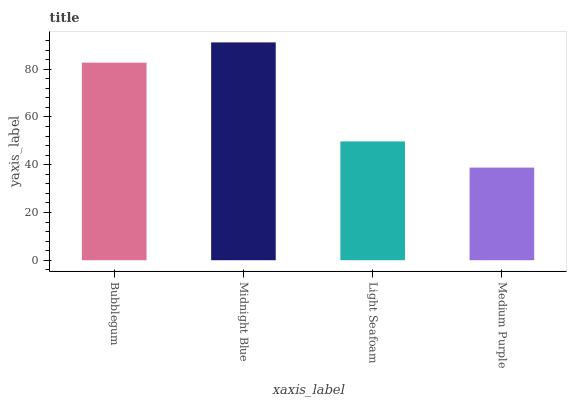Is Medium Purple the minimum?
Answer yes or no. Yes. Is Midnight Blue the maximum?
Answer yes or no. Yes. Is Light Seafoam the minimum?
Answer yes or no. No. Is Light Seafoam the maximum?
Answer yes or no. No. Is Midnight Blue greater than Light Seafoam?
Answer yes or no. Yes. Is Light Seafoam less than Midnight Blue?
Answer yes or no. Yes. Is Light Seafoam greater than Midnight Blue?
Answer yes or no. No. Is Midnight Blue less than Light Seafoam?
Answer yes or no. No. Is Bubblegum the high median?
Answer yes or no. Yes. Is Light Seafoam the low median?
Answer yes or no. Yes. Is Midnight Blue the high median?
Answer yes or no. No. Is Medium Purple the low median?
Answer yes or no. No. 